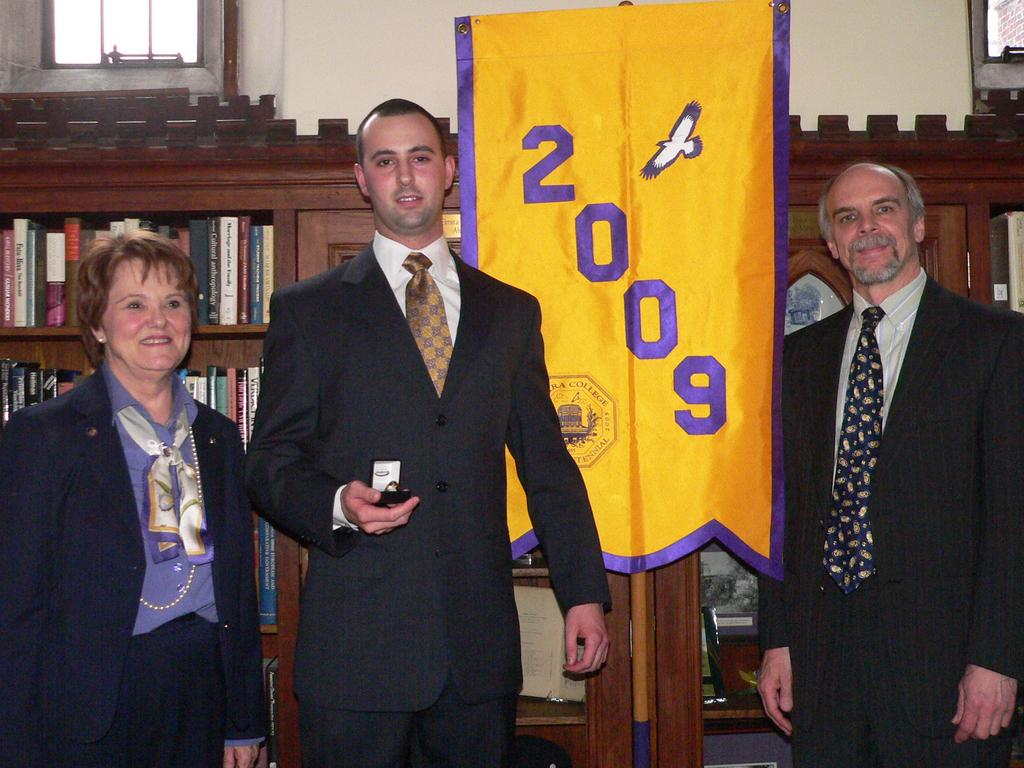How many people are in the image? There are three persons in the image. What are the people wearing? All three persons are wearing suits. What is one of the men holding? One of the men is holding a ring. What can be seen in the background of the image? There is a bookshelf, a flag, and a wall in the background of the image. What type of van can be seen in the image? There is no van present in the image. What kind of polish is being used on the bone in the image? There is no bone or polish present in the image. 